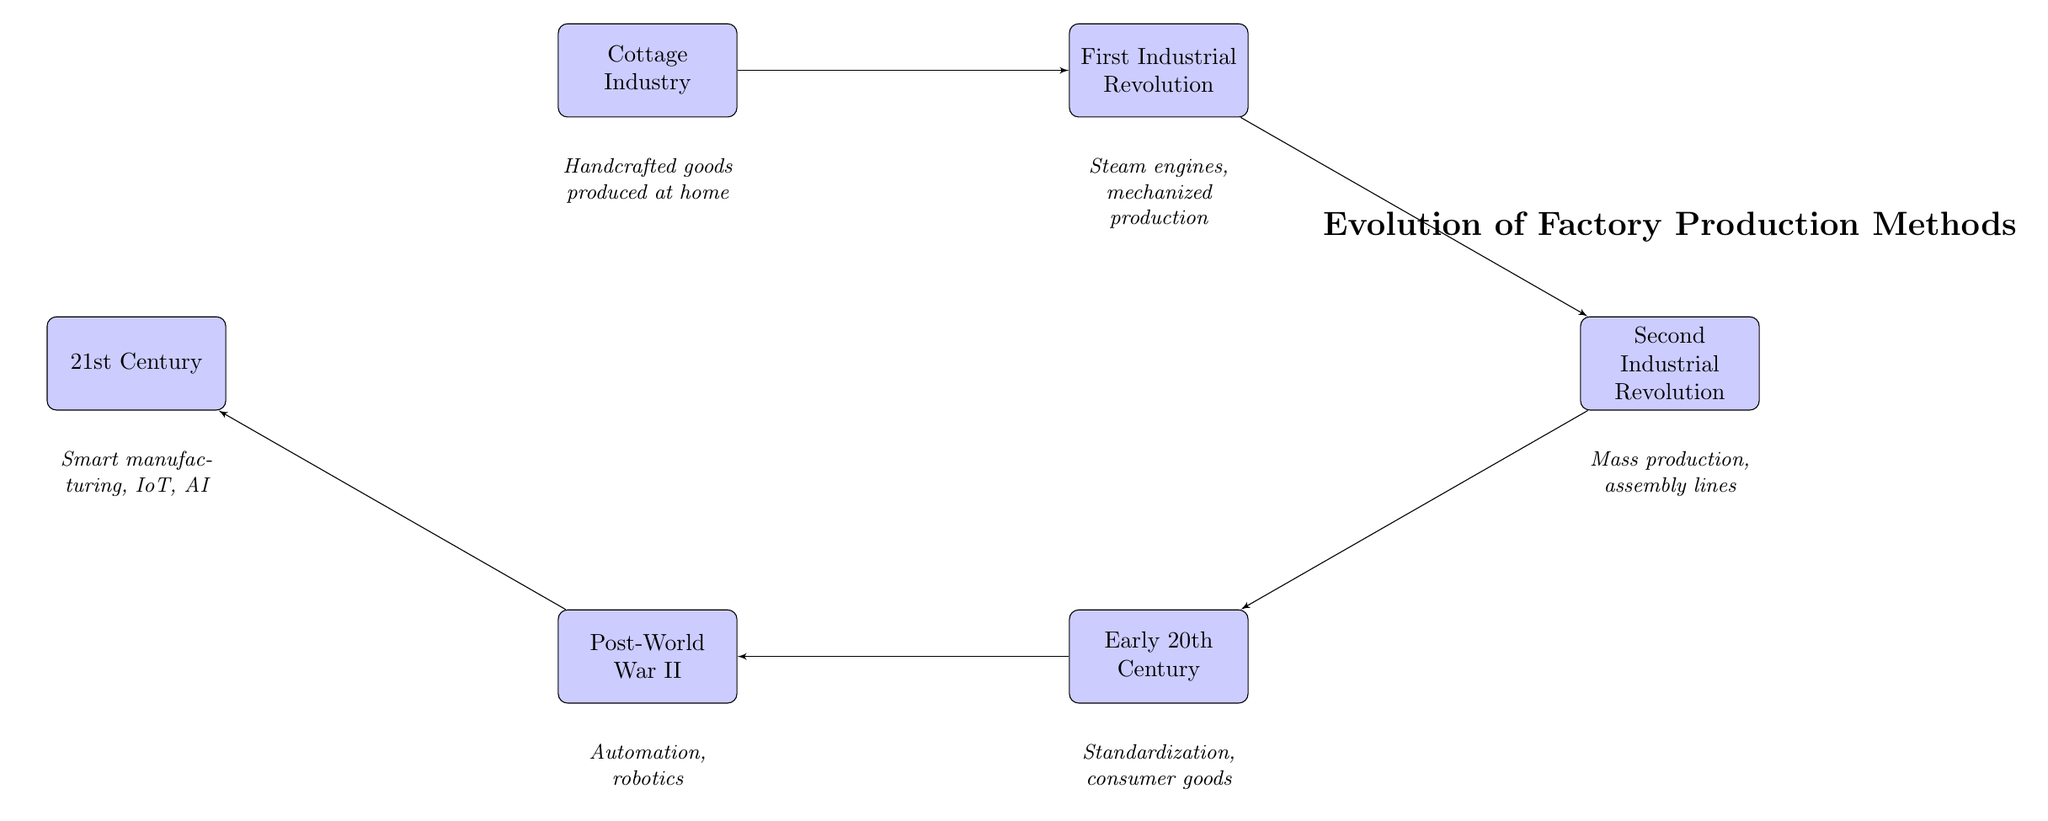What is the first method of production in the diagram? The first node in the flow chart represents the "Cottage Industry," which is the starting point of the production methods presented.
Answer: Cottage Industry Which production method introduced steam engines? The node that mentions the introduction of steam engines is the "First Industrial Revolution," which directly follows the "Cottage Industry" in the flow of the diagram.
Answer: First Industrial Revolution How many production methods are shown in the diagram? By counting the number of nodes presented in the flow chart, we find there are six distinct production methods listed.
Answer: 6 What is the key development in the Second Industrial Revolution? The "Second Industrial Revolution" node highlights mass production and assembly lines as its key developments, which are consolidated under this production method.
Answer: Mass production, assembly lines What comes after the Early 20th Century in the diagram? To find what follows the "Early 20th Century," we look at the arrows leading from this node; it points directly to the "Post-World War II" method, signifying its position in the sequence.
Answer: Post-World War II In which period did factories begin producing consumer goods? The description under the "Early 20th Century" node clearly denotes that this period marked the introduction of factories that produce consumer goods.
Answer: Early 20th Century What advancement is associated with 21st Century manufacturing? The description under the "21st Century" node indicates that this period includes advancements in smart manufacturing, IoT, and AI, which are the main highlights of this era.
Answer: Smart manufacturing, IoT, AI Which production method is characterized by automation and robotics? The node called "Post-World War II" explicitly states the key attributes of this period, including the significant advancements in automation and robotics.
Answer: Post-World War II 